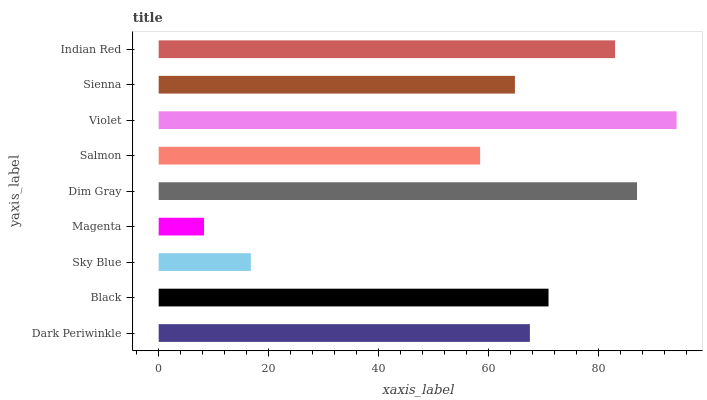Is Magenta the minimum?
Answer yes or no. Yes. Is Violet the maximum?
Answer yes or no. Yes. Is Black the minimum?
Answer yes or no. No. Is Black the maximum?
Answer yes or no. No. Is Black greater than Dark Periwinkle?
Answer yes or no. Yes. Is Dark Periwinkle less than Black?
Answer yes or no. Yes. Is Dark Periwinkle greater than Black?
Answer yes or no. No. Is Black less than Dark Periwinkle?
Answer yes or no. No. Is Dark Periwinkle the high median?
Answer yes or no. Yes. Is Dark Periwinkle the low median?
Answer yes or no. Yes. Is Black the high median?
Answer yes or no. No. Is Magenta the low median?
Answer yes or no. No. 